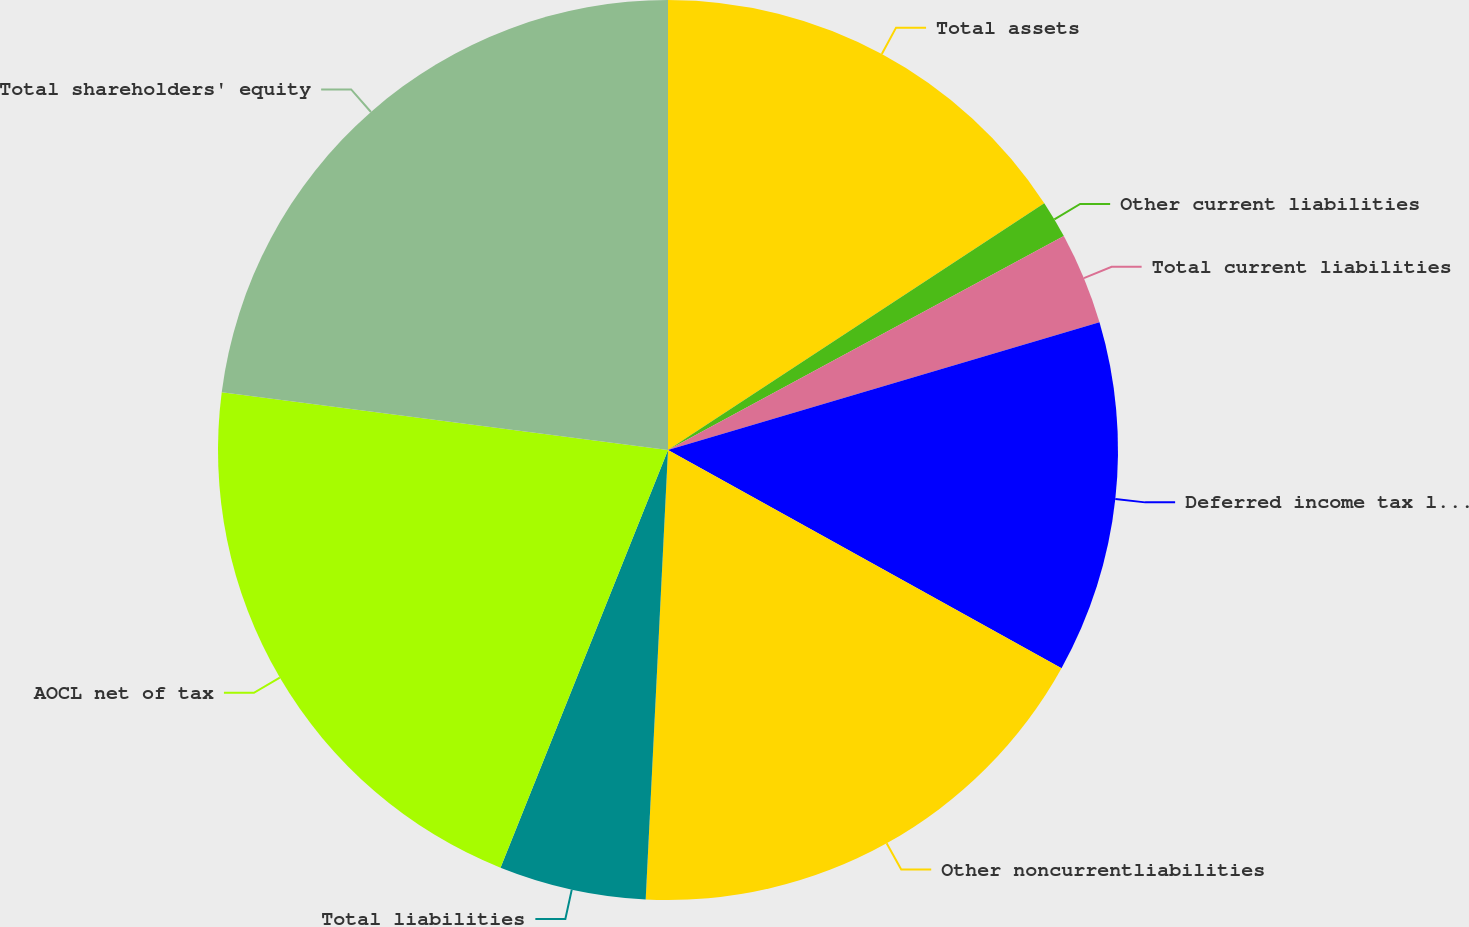Convert chart to OTSL. <chart><loc_0><loc_0><loc_500><loc_500><pie_chart><fcel>Total assets<fcel>Other current liabilities<fcel>Total current liabilities<fcel>Deferred income tax liability<fcel>Other noncurrentliabilities<fcel>Total liabilities<fcel>AOCL net of tax<fcel>Total shareholders' equity<nl><fcel>15.76%<fcel>1.35%<fcel>3.31%<fcel>12.64%<fcel>17.73%<fcel>5.28%<fcel>20.98%<fcel>22.95%<nl></chart> 